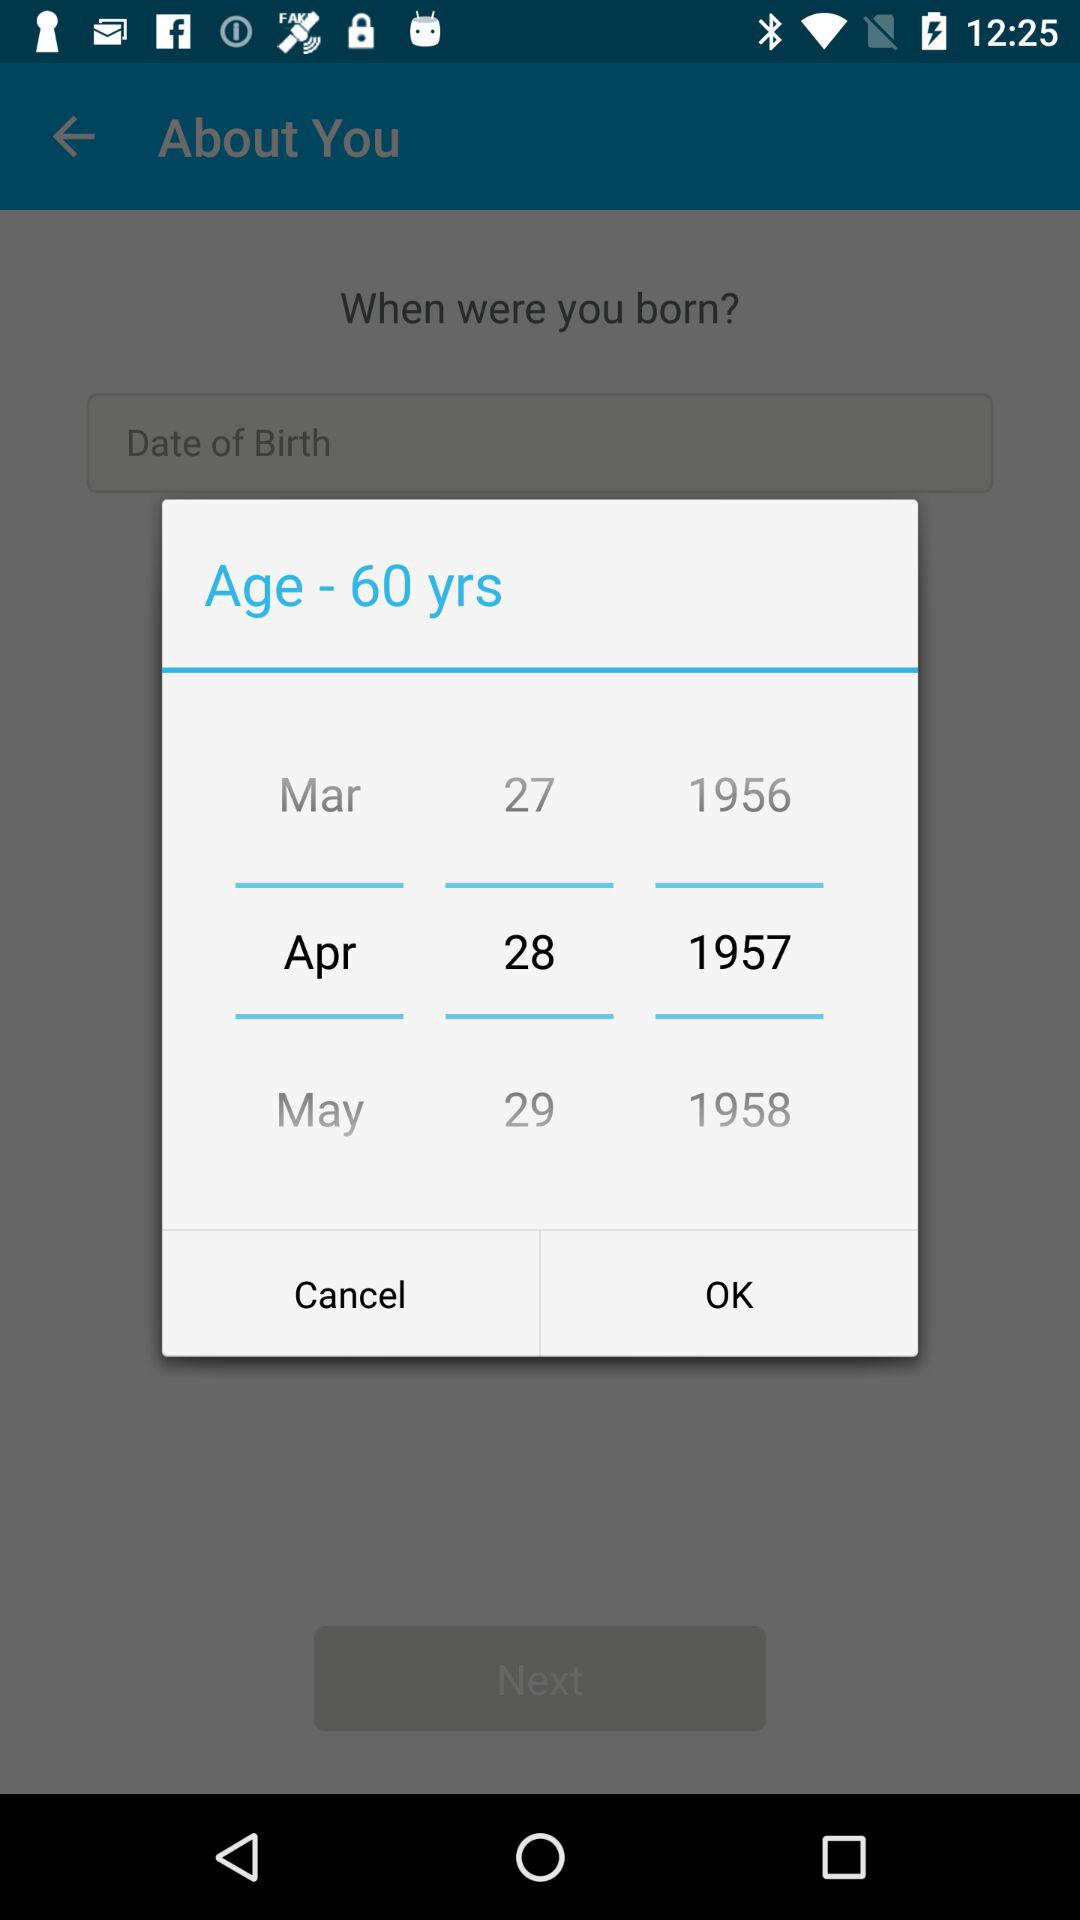What is the selected month in the calendar? The selected month is April. 